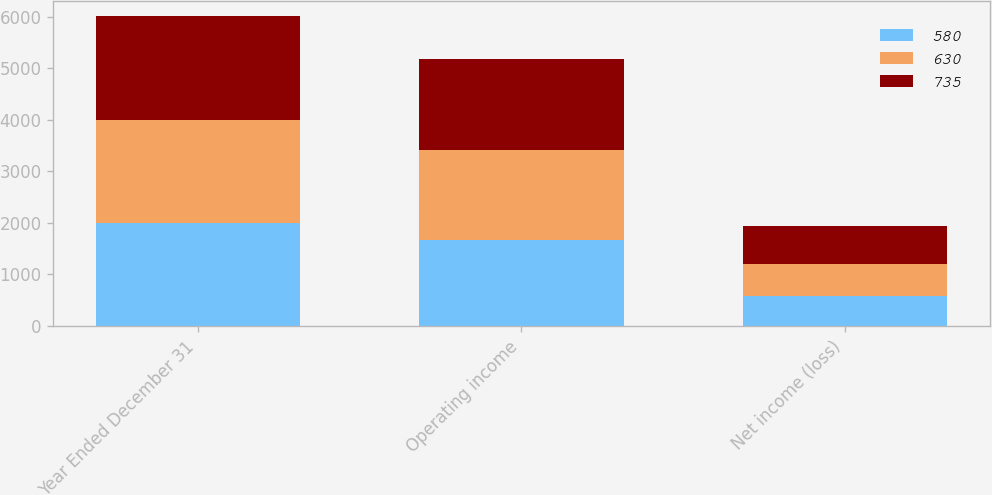<chart> <loc_0><loc_0><loc_500><loc_500><stacked_bar_chart><ecel><fcel>Year Ended December 31<fcel>Operating income<fcel>Net income (loss)<nl><fcel>580<fcel>2003<fcel>1666<fcel>580<nl><fcel>630<fcel>2002<fcel>1744<fcel>630<nl><fcel>735<fcel>2001<fcel>1770<fcel>735<nl></chart> 